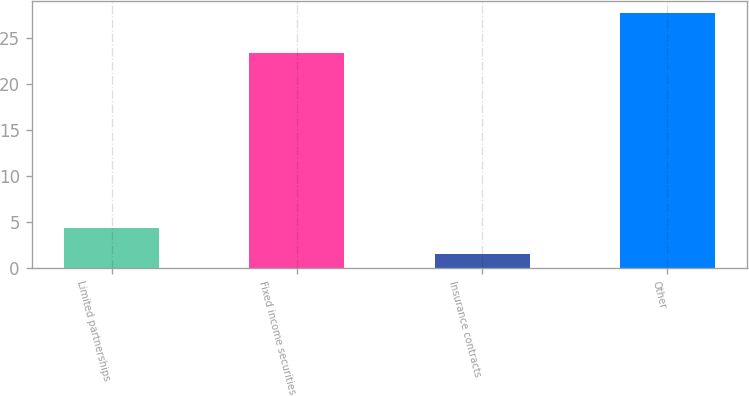<chart> <loc_0><loc_0><loc_500><loc_500><bar_chart><fcel>Limited partnerships<fcel>Fixed income securities<fcel>Insurance contracts<fcel>Other<nl><fcel>4.36<fcel>23.4<fcel>1.5<fcel>27.7<nl></chart> 